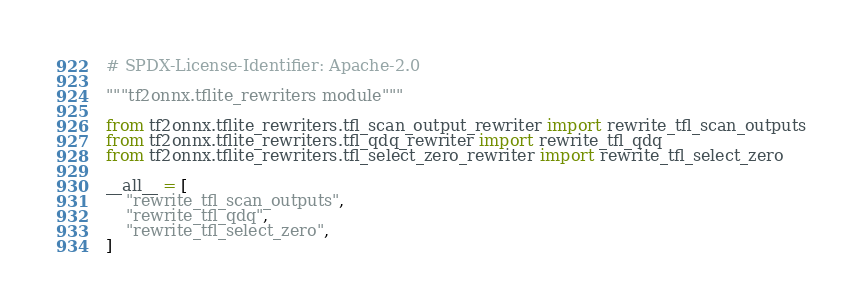<code> <loc_0><loc_0><loc_500><loc_500><_Python_># SPDX-License-Identifier: Apache-2.0

"""tf2onnx.tflite_rewriters module"""

from tf2onnx.tflite_rewriters.tfl_scan_output_rewriter import rewrite_tfl_scan_outputs
from tf2onnx.tflite_rewriters.tfl_qdq_rewriter import rewrite_tfl_qdq
from tf2onnx.tflite_rewriters.tfl_select_zero_rewriter import rewrite_tfl_select_zero

__all__ = [
    "rewrite_tfl_scan_outputs",
    "rewrite_tfl_qdq",
    "rewrite_tfl_select_zero",
]
</code> 